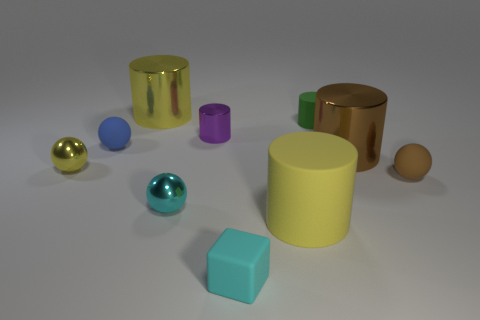Subtract all yellow balls. How many balls are left? 3 Subtract all cyan spheres. How many spheres are left? 3 Subtract 0 blue cylinders. How many objects are left? 10 Subtract all spheres. How many objects are left? 6 Subtract 4 spheres. How many spheres are left? 0 Subtract all red cylinders. Subtract all red balls. How many cylinders are left? 5 Subtract all gray spheres. How many yellow blocks are left? 0 Subtract all large metal objects. Subtract all brown metal things. How many objects are left? 7 Add 5 cyan matte cubes. How many cyan matte cubes are left? 6 Add 2 brown metal cylinders. How many brown metal cylinders exist? 3 